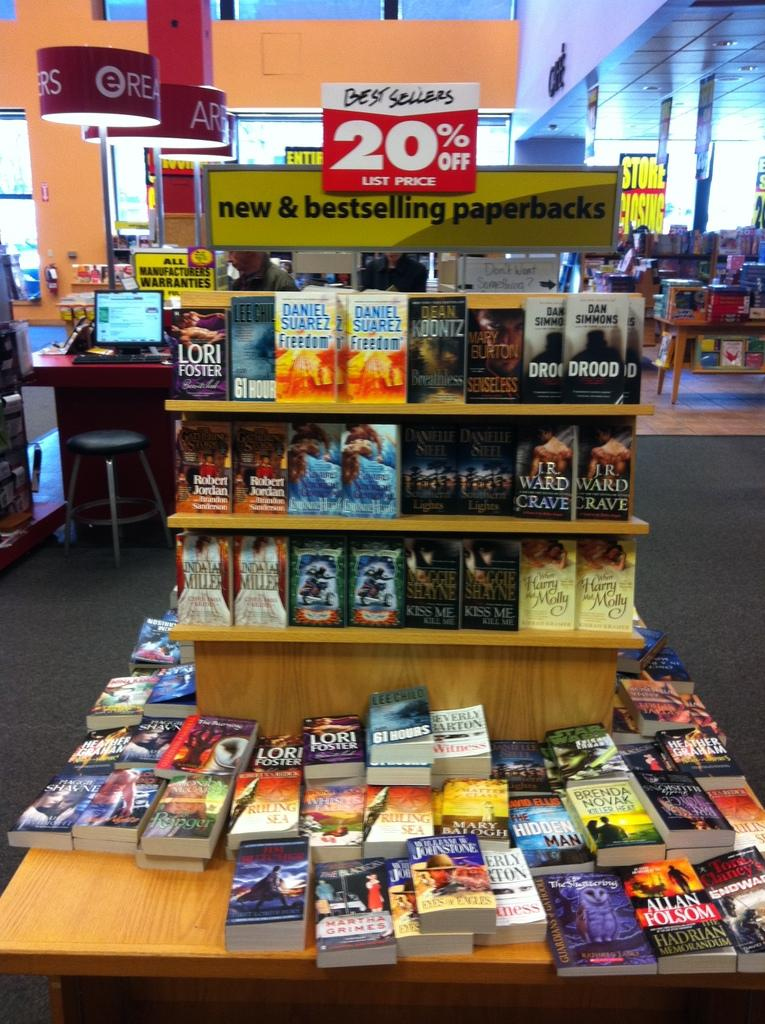Provide a one-sentence caption for the provided image. A book stand full of books that are 20% off. 